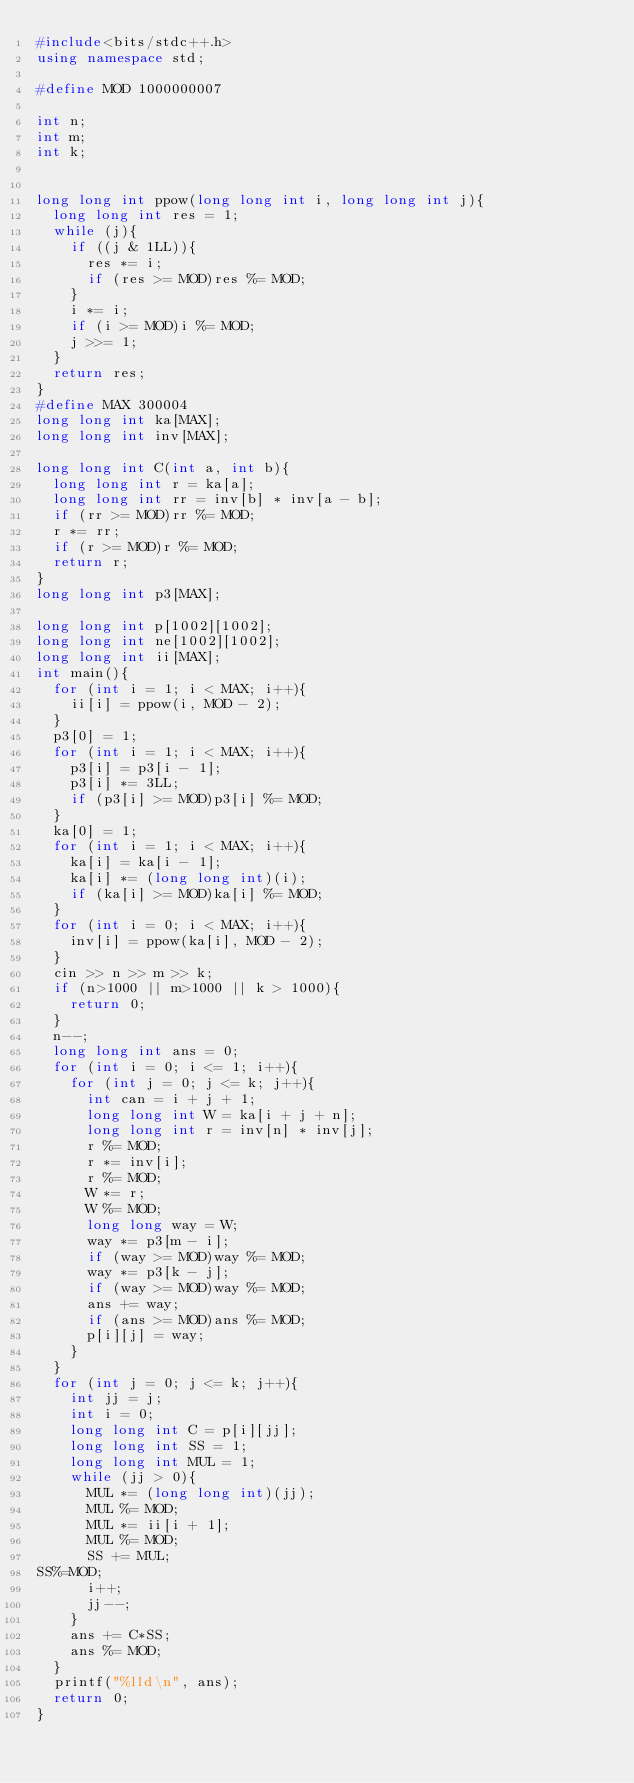<code> <loc_0><loc_0><loc_500><loc_500><_C++_>#include<bits/stdc++.h>
using namespace std;

#define MOD 1000000007

int n;
int m; 
int k;


long long int ppow(long long int i, long long int j){
	long long int res = 1;
	while (j){
		if ((j & 1LL)){
			res *= i;
			if (res >= MOD)res %= MOD;
		}
		i *= i;
		if (i >= MOD)i %= MOD;
		j >>= 1;
	}
	return res;
}
#define MAX 300004
long long int ka[MAX];
long long int inv[MAX];

long long int C(int a, int b){
	long long int r = ka[a];
	long long int rr = inv[b] * inv[a - b]; 
	if (rr >= MOD)rr %= MOD;
	r *= rr;
	if (r >= MOD)r %= MOD;
	return r;
}
long long int p3[MAX];

long long int p[1002][1002];
long long int ne[1002][1002];
long long int ii[MAX];
int main(){
	for (int i = 1; i < MAX; i++){
		ii[i] = ppow(i, MOD - 2);
	}
	p3[0] = 1;
	for (int i = 1; i < MAX; i++){
		p3[i] = p3[i - 1];
		p3[i] *= 3LL;
		if (p3[i] >= MOD)p3[i] %= MOD;
	}
	ka[0] = 1;
	for (int i = 1; i < MAX; i++){
		ka[i] = ka[i - 1];
		ka[i] *= (long long int)(i);
		if (ka[i] >= MOD)ka[i] %= MOD;
	}
	for (int i = 0; i < MAX; i++){
		inv[i] = ppow(ka[i], MOD - 2);
	}
	cin >> n >> m >> k;
	if (n>1000 || m>1000 || k > 1000){
		return 0;
	}
	n--;
	long long int ans = 0;
	for (int i = 0; i <= 1; i++){
		for (int j = 0; j <= k; j++){
			int can = i + j + 1;
			long long int W = ka[i + j + n];
			long long int r = inv[n] * inv[j];
			r %= MOD;
			r *= inv[i];
			r %= MOD;
			W *= r;
			W %= MOD;
			long long way = W;
			way *= p3[m - i];
			if (way >= MOD)way %= MOD;
			way *= p3[k - j];
			if (way >= MOD)way %= MOD;
			ans += way;
			if (ans >= MOD)ans %= MOD;
			p[i][j] = way;
		}
	}
	for (int j = 0; j <= k; j++){
		int jj = j;
		int i = 0;
		long long int C = p[i][jj];
		long long int SS = 1;
		long long int MUL = 1;
		while (jj > 0){
			MUL *= (long long int)(jj);
			MUL %= MOD;
			MUL *= ii[i + 1];
			MUL %= MOD;
			SS += MUL;
SS%=MOD;
			i++;
			jj--;
		}
		ans += C*SS;
		ans %= MOD;
	}
	printf("%lld\n", ans);
	return 0;
}</code> 